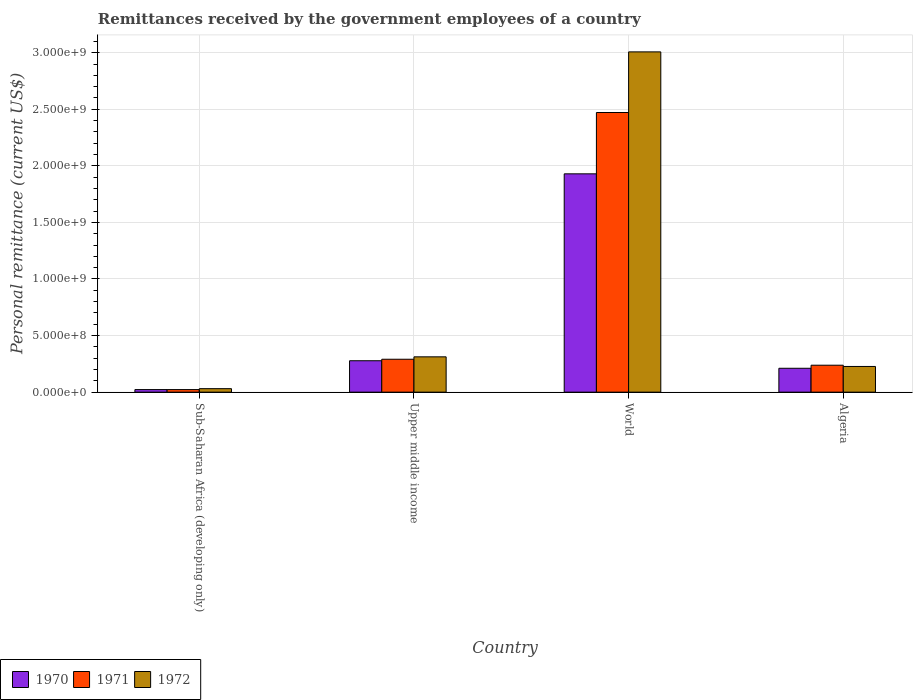How many groups of bars are there?
Give a very brief answer. 4. Are the number of bars per tick equal to the number of legend labels?
Keep it short and to the point. Yes. How many bars are there on the 4th tick from the left?
Your answer should be very brief. 3. What is the label of the 1st group of bars from the left?
Offer a very short reply. Sub-Saharan Africa (developing only). In how many cases, is the number of bars for a given country not equal to the number of legend labels?
Provide a short and direct response. 0. What is the remittances received by the government employees in 1971 in Sub-Saharan Africa (developing only)?
Provide a succinct answer. 2.26e+07. Across all countries, what is the maximum remittances received by the government employees in 1970?
Keep it short and to the point. 1.93e+09. Across all countries, what is the minimum remittances received by the government employees in 1972?
Provide a succinct answer. 3.07e+07. In which country was the remittances received by the government employees in 1970 minimum?
Provide a succinct answer. Sub-Saharan Africa (developing only). What is the total remittances received by the government employees in 1970 in the graph?
Ensure brevity in your answer.  2.44e+09. What is the difference between the remittances received by the government employees in 1972 in Algeria and that in World?
Make the answer very short. -2.78e+09. What is the difference between the remittances received by the government employees in 1971 in World and the remittances received by the government employees in 1970 in Algeria?
Ensure brevity in your answer.  2.26e+09. What is the average remittances received by the government employees in 1971 per country?
Provide a short and direct response. 7.56e+08. What is the difference between the remittances received by the government employees of/in 1971 and remittances received by the government employees of/in 1970 in Upper middle income?
Offer a terse response. 1.32e+07. In how many countries, is the remittances received by the government employees in 1970 greater than 1600000000 US$?
Keep it short and to the point. 1. What is the ratio of the remittances received by the government employees in 1972 in Sub-Saharan Africa (developing only) to that in World?
Keep it short and to the point. 0.01. Is the remittances received by the government employees in 1971 in Sub-Saharan Africa (developing only) less than that in Upper middle income?
Your answer should be compact. Yes. Is the difference between the remittances received by the government employees in 1971 in Algeria and World greater than the difference between the remittances received by the government employees in 1970 in Algeria and World?
Provide a succinct answer. No. What is the difference between the highest and the second highest remittances received by the government employees in 1971?
Give a very brief answer. -2.23e+09. What is the difference between the highest and the lowest remittances received by the government employees in 1972?
Keep it short and to the point. 2.98e+09. In how many countries, is the remittances received by the government employees in 1971 greater than the average remittances received by the government employees in 1971 taken over all countries?
Offer a terse response. 1. Is the sum of the remittances received by the government employees in 1972 in Sub-Saharan Africa (developing only) and World greater than the maximum remittances received by the government employees in 1970 across all countries?
Provide a short and direct response. Yes. What does the 3rd bar from the left in World represents?
Keep it short and to the point. 1972. Is it the case that in every country, the sum of the remittances received by the government employees in 1970 and remittances received by the government employees in 1971 is greater than the remittances received by the government employees in 1972?
Provide a succinct answer. Yes. How many bars are there?
Offer a very short reply. 12. What is the difference between two consecutive major ticks on the Y-axis?
Provide a short and direct response. 5.00e+08. Does the graph contain any zero values?
Ensure brevity in your answer.  No. Does the graph contain grids?
Provide a succinct answer. Yes. How many legend labels are there?
Give a very brief answer. 3. How are the legend labels stacked?
Give a very brief answer. Horizontal. What is the title of the graph?
Keep it short and to the point. Remittances received by the government employees of a country. What is the label or title of the X-axis?
Your answer should be very brief. Country. What is the label or title of the Y-axis?
Your answer should be compact. Personal remittance (current US$). What is the Personal remittance (current US$) in 1970 in Sub-Saharan Africa (developing only)?
Your answer should be compact. 2.27e+07. What is the Personal remittance (current US$) in 1971 in Sub-Saharan Africa (developing only)?
Offer a very short reply. 2.26e+07. What is the Personal remittance (current US$) of 1972 in Sub-Saharan Africa (developing only)?
Your answer should be very brief. 3.07e+07. What is the Personal remittance (current US$) in 1970 in Upper middle income?
Offer a very short reply. 2.77e+08. What is the Personal remittance (current US$) in 1971 in Upper middle income?
Provide a succinct answer. 2.91e+08. What is the Personal remittance (current US$) of 1972 in Upper middle income?
Keep it short and to the point. 3.12e+08. What is the Personal remittance (current US$) of 1970 in World?
Your answer should be compact. 1.93e+09. What is the Personal remittance (current US$) of 1971 in World?
Provide a short and direct response. 2.47e+09. What is the Personal remittance (current US$) in 1972 in World?
Your answer should be compact. 3.01e+09. What is the Personal remittance (current US$) of 1970 in Algeria?
Your answer should be very brief. 2.11e+08. What is the Personal remittance (current US$) in 1971 in Algeria?
Provide a succinct answer. 2.38e+08. What is the Personal remittance (current US$) in 1972 in Algeria?
Make the answer very short. 2.27e+08. Across all countries, what is the maximum Personal remittance (current US$) in 1970?
Make the answer very short. 1.93e+09. Across all countries, what is the maximum Personal remittance (current US$) of 1971?
Your answer should be compact. 2.47e+09. Across all countries, what is the maximum Personal remittance (current US$) in 1972?
Provide a succinct answer. 3.01e+09. Across all countries, what is the minimum Personal remittance (current US$) in 1970?
Provide a succinct answer. 2.27e+07. Across all countries, what is the minimum Personal remittance (current US$) in 1971?
Your answer should be compact. 2.26e+07. Across all countries, what is the minimum Personal remittance (current US$) of 1972?
Offer a very short reply. 3.07e+07. What is the total Personal remittance (current US$) of 1970 in the graph?
Offer a terse response. 2.44e+09. What is the total Personal remittance (current US$) in 1971 in the graph?
Your answer should be very brief. 3.02e+09. What is the total Personal remittance (current US$) in 1972 in the graph?
Offer a very short reply. 3.58e+09. What is the difference between the Personal remittance (current US$) in 1970 in Sub-Saharan Africa (developing only) and that in Upper middle income?
Offer a very short reply. -2.55e+08. What is the difference between the Personal remittance (current US$) of 1971 in Sub-Saharan Africa (developing only) and that in Upper middle income?
Make the answer very short. -2.68e+08. What is the difference between the Personal remittance (current US$) in 1972 in Sub-Saharan Africa (developing only) and that in Upper middle income?
Make the answer very short. -2.81e+08. What is the difference between the Personal remittance (current US$) of 1970 in Sub-Saharan Africa (developing only) and that in World?
Provide a succinct answer. -1.91e+09. What is the difference between the Personal remittance (current US$) in 1971 in Sub-Saharan Africa (developing only) and that in World?
Your response must be concise. -2.45e+09. What is the difference between the Personal remittance (current US$) in 1972 in Sub-Saharan Africa (developing only) and that in World?
Provide a short and direct response. -2.98e+09. What is the difference between the Personal remittance (current US$) of 1970 in Sub-Saharan Africa (developing only) and that in Algeria?
Make the answer very short. -1.88e+08. What is the difference between the Personal remittance (current US$) of 1971 in Sub-Saharan Africa (developing only) and that in Algeria?
Your answer should be very brief. -2.15e+08. What is the difference between the Personal remittance (current US$) in 1972 in Sub-Saharan Africa (developing only) and that in Algeria?
Offer a terse response. -1.96e+08. What is the difference between the Personal remittance (current US$) of 1970 in Upper middle income and that in World?
Keep it short and to the point. -1.65e+09. What is the difference between the Personal remittance (current US$) in 1971 in Upper middle income and that in World?
Ensure brevity in your answer.  -2.18e+09. What is the difference between the Personal remittance (current US$) in 1972 in Upper middle income and that in World?
Provide a succinct answer. -2.70e+09. What is the difference between the Personal remittance (current US$) of 1970 in Upper middle income and that in Algeria?
Offer a very short reply. 6.65e+07. What is the difference between the Personal remittance (current US$) of 1971 in Upper middle income and that in Algeria?
Provide a succinct answer. 5.27e+07. What is the difference between the Personal remittance (current US$) in 1972 in Upper middle income and that in Algeria?
Make the answer very short. 8.50e+07. What is the difference between the Personal remittance (current US$) of 1970 in World and that in Algeria?
Your answer should be compact. 1.72e+09. What is the difference between the Personal remittance (current US$) of 1971 in World and that in Algeria?
Provide a short and direct response. 2.23e+09. What is the difference between the Personal remittance (current US$) of 1972 in World and that in Algeria?
Keep it short and to the point. 2.78e+09. What is the difference between the Personal remittance (current US$) in 1970 in Sub-Saharan Africa (developing only) and the Personal remittance (current US$) in 1971 in Upper middle income?
Offer a terse response. -2.68e+08. What is the difference between the Personal remittance (current US$) of 1970 in Sub-Saharan Africa (developing only) and the Personal remittance (current US$) of 1972 in Upper middle income?
Offer a terse response. -2.89e+08. What is the difference between the Personal remittance (current US$) of 1971 in Sub-Saharan Africa (developing only) and the Personal remittance (current US$) of 1972 in Upper middle income?
Give a very brief answer. -2.89e+08. What is the difference between the Personal remittance (current US$) in 1970 in Sub-Saharan Africa (developing only) and the Personal remittance (current US$) in 1971 in World?
Provide a succinct answer. -2.45e+09. What is the difference between the Personal remittance (current US$) of 1970 in Sub-Saharan Africa (developing only) and the Personal remittance (current US$) of 1972 in World?
Ensure brevity in your answer.  -2.98e+09. What is the difference between the Personal remittance (current US$) of 1971 in Sub-Saharan Africa (developing only) and the Personal remittance (current US$) of 1972 in World?
Ensure brevity in your answer.  -2.98e+09. What is the difference between the Personal remittance (current US$) of 1970 in Sub-Saharan Africa (developing only) and the Personal remittance (current US$) of 1971 in Algeria?
Provide a short and direct response. -2.15e+08. What is the difference between the Personal remittance (current US$) in 1970 in Sub-Saharan Africa (developing only) and the Personal remittance (current US$) in 1972 in Algeria?
Offer a terse response. -2.04e+08. What is the difference between the Personal remittance (current US$) in 1971 in Sub-Saharan Africa (developing only) and the Personal remittance (current US$) in 1972 in Algeria?
Your response must be concise. -2.04e+08. What is the difference between the Personal remittance (current US$) in 1970 in Upper middle income and the Personal remittance (current US$) in 1971 in World?
Provide a succinct answer. -2.19e+09. What is the difference between the Personal remittance (current US$) of 1970 in Upper middle income and the Personal remittance (current US$) of 1972 in World?
Provide a succinct answer. -2.73e+09. What is the difference between the Personal remittance (current US$) in 1971 in Upper middle income and the Personal remittance (current US$) in 1972 in World?
Make the answer very short. -2.72e+09. What is the difference between the Personal remittance (current US$) of 1970 in Upper middle income and the Personal remittance (current US$) of 1971 in Algeria?
Give a very brief answer. 3.95e+07. What is the difference between the Personal remittance (current US$) in 1970 in Upper middle income and the Personal remittance (current US$) in 1972 in Algeria?
Offer a very short reply. 5.05e+07. What is the difference between the Personal remittance (current US$) in 1971 in Upper middle income and the Personal remittance (current US$) in 1972 in Algeria?
Make the answer very short. 6.37e+07. What is the difference between the Personal remittance (current US$) in 1970 in World and the Personal remittance (current US$) in 1971 in Algeria?
Give a very brief answer. 1.69e+09. What is the difference between the Personal remittance (current US$) of 1970 in World and the Personal remittance (current US$) of 1972 in Algeria?
Provide a short and direct response. 1.70e+09. What is the difference between the Personal remittance (current US$) of 1971 in World and the Personal remittance (current US$) of 1972 in Algeria?
Your response must be concise. 2.24e+09. What is the average Personal remittance (current US$) of 1970 per country?
Your answer should be compact. 6.10e+08. What is the average Personal remittance (current US$) in 1971 per country?
Make the answer very short. 7.56e+08. What is the average Personal remittance (current US$) of 1972 per country?
Your answer should be compact. 8.94e+08. What is the difference between the Personal remittance (current US$) of 1970 and Personal remittance (current US$) of 1971 in Sub-Saharan Africa (developing only)?
Your response must be concise. 2.18e+04. What is the difference between the Personal remittance (current US$) of 1970 and Personal remittance (current US$) of 1972 in Sub-Saharan Africa (developing only)?
Make the answer very short. -8.07e+06. What is the difference between the Personal remittance (current US$) in 1971 and Personal remittance (current US$) in 1972 in Sub-Saharan Africa (developing only)?
Ensure brevity in your answer.  -8.09e+06. What is the difference between the Personal remittance (current US$) of 1970 and Personal remittance (current US$) of 1971 in Upper middle income?
Your response must be concise. -1.32e+07. What is the difference between the Personal remittance (current US$) of 1970 and Personal remittance (current US$) of 1972 in Upper middle income?
Offer a terse response. -3.45e+07. What is the difference between the Personal remittance (current US$) of 1971 and Personal remittance (current US$) of 1972 in Upper middle income?
Keep it short and to the point. -2.13e+07. What is the difference between the Personal remittance (current US$) in 1970 and Personal remittance (current US$) in 1971 in World?
Keep it short and to the point. -5.42e+08. What is the difference between the Personal remittance (current US$) in 1970 and Personal remittance (current US$) in 1972 in World?
Your response must be concise. -1.08e+09. What is the difference between the Personal remittance (current US$) of 1971 and Personal remittance (current US$) of 1972 in World?
Your response must be concise. -5.36e+08. What is the difference between the Personal remittance (current US$) in 1970 and Personal remittance (current US$) in 1971 in Algeria?
Your response must be concise. -2.70e+07. What is the difference between the Personal remittance (current US$) in 1970 and Personal remittance (current US$) in 1972 in Algeria?
Provide a succinct answer. -1.60e+07. What is the difference between the Personal remittance (current US$) of 1971 and Personal remittance (current US$) of 1972 in Algeria?
Keep it short and to the point. 1.10e+07. What is the ratio of the Personal remittance (current US$) of 1970 in Sub-Saharan Africa (developing only) to that in Upper middle income?
Provide a short and direct response. 0.08. What is the ratio of the Personal remittance (current US$) in 1971 in Sub-Saharan Africa (developing only) to that in Upper middle income?
Offer a terse response. 0.08. What is the ratio of the Personal remittance (current US$) in 1972 in Sub-Saharan Africa (developing only) to that in Upper middle income?
Your response must be concise. 0.1. What is the ratio of the Personal remittance (current US$) in 1970 in Sub-Saharan Africa (developing only) to that in World?
Provide a short and direct response. 0.01. What is the ratio of the Personal remittance (current US$) in 1971 in Sub-Saharan Africa (developing only) to that in World?
Keep it short and to the point. 0.01. What is the ratio of the Personal remittance (current US$) of 1972 in Sub-Saharan Africa (developing only) to that in World?
Your response must be concise. 0.01. What is the ratio of the Personal remittance (current US$) of 1970 in Sub-Saharan Africa (developing only) to that in Algeria?
Your response must be concise. 0.11. What is the ratio of the Personal remittance (current US$) in 1971 in Sub-Saharan Africa (developing only) to that in Algeria?
Ensure brevity in your answer.  0.1. What is the ratio of the Personal remittance (current US$) of 1972 in Sub-Saharan Africa (developing only) to that in Algeria?
Offer a very short reply. 0.14. What is the ratio of the Personal remittance (current US$) of 1970 in Upper middle income to that in World?
Provide a short and direct response. 0.14. What is the ratio of the Personal remittance (current US$) in 1971 in Upper middle income to that in World?
Provide a short and direct response. 0.12. What is the ratio of the Personal remittance (current US$) of 1972 in Upper middle income to that in World?
Make the answer very short. 0.1. What is the ratio of the Personal remittance (current US$) of 1970 in Upper middle income to that in Algeria?
Your response must be concise. 1.32. What is the ratio of the Personal remittance (current US$) of 1971 in Upper middle income to that in Algeria?
Give a very brief answer. 1.22. What is the ratio of the Personal remittance (current US$) in 1972 in Upper middle income to that in Algeria?
Ensure brevity in your answer.  1.37. What is the ratio of the Personal remittance (current US$) of 1970 in World to that in Algeria?
Provide a succinct answer. 9.14. What is the ratio of the Personal remittance (current US$) in 1971 in World to that in Algeria?
Give a very brief answer. 10.38. What is the ratio of the Personal remittance (current US$) in 1972 in World to that in Algeria?
Provide a short and direct response. 13.25. What is the difference between the highest and the second highest Personal remittance (current US$) in 1970?
Your answer should be very brief. 1.65e+09. What is the difference between the highest and the second highest Personal remittance (current US$) of 1971?
Offer a very short reply. 2.18e+09. What is the difference between the highest and the second highest Personal remittance (current US$) of 1972?
Provide a short and direct response. 2.70e+09. What is the difference between the highest and the lowest Personal remittance (current US$) of 1970?
Your answer should be very brief. 1.91e+09. What is the difference between the highest and the lowest Personal remittance (current US$) in 1971?
Make the answer very short. 2.45e+09. What is the difference between the highest and the lowest Personal remittance (current US$) of 1972?
Offer a very short reply. 2.98e+09. 